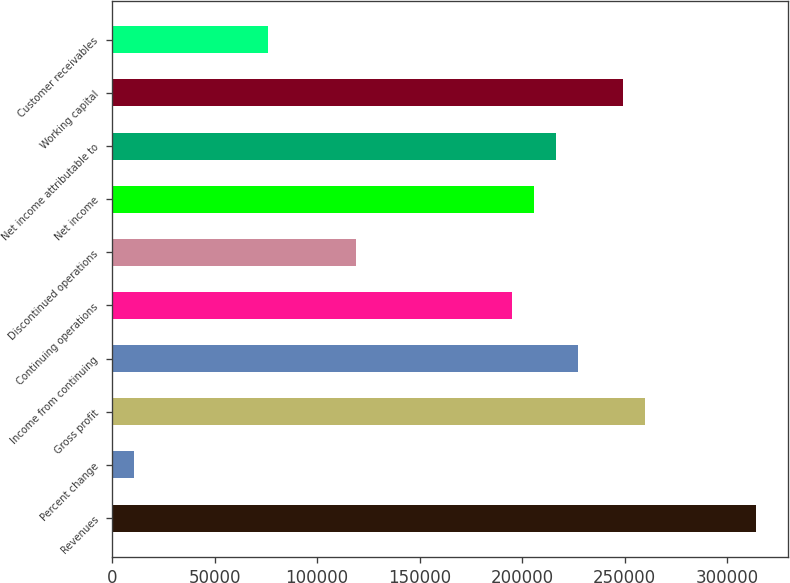Convert chart to OTSL. <chart><loc_0><loc_0><loc_500><loc_500><bar_chart><fcel>Revenues<fcel>Percent change<fcel>Gross profit<fcel>Income from continuing<fcel>Continuing operations<fcel>Discontinued operations<fcel>Net income<fcel>Net income attributable to<fcel>Working capital<fcel>Customer receivables<nl><fcel>314055<fcel>10829.9<fcel>259907<fcel>227419<fcel>194931<fcel>119124<fcel>205760<fcel>216589<fcel>249078<fcel>75806.6<nl></chart> 